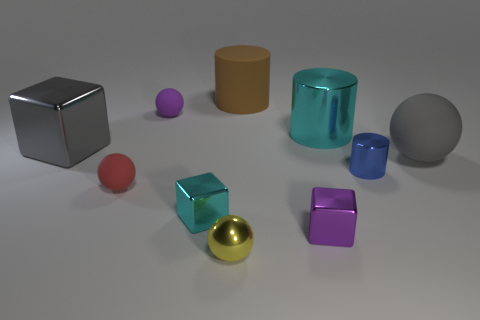There is a purple thing behind the purple object that is in front of the blue thing; what size is it?
Offer a terse response. Small. Are there an equal number of large gray metallic cubes to the left of the gray shiny block and tiny cyan metal blocks that are on the right side of the large gray rubber sphere?
Make the answer very short. Yes. Are there any other things that have the same size as the purple matte thing?
Offer a terse response. Yes. What color is the big block that is the same material as the tiny purple cube?
Offer a terse response. Gray. Do the red ball and the cyan object in front of the large gray cube have the same material?
Keep it short and to the point. No. What color is the metallic thing that is both in front of the large metal cube and to the right of the small purple shiny thing?
Provide a succinct answer. Blue. What number of cylinders are small cyan objects or red things?
Give a very brief answer. 0. There is a yellow thing; does it have the same shape as the cyan object behind the large gray ball?
Your answer should be compact. No. There is a rubber thing that is both left of the purple metallic block and in front of the purple rubber ball; how big is it?
Ensure brevity in your answer.  Small. There is a tiny purple metal thing; what shape is it?
Your response must be concise. Cube. 